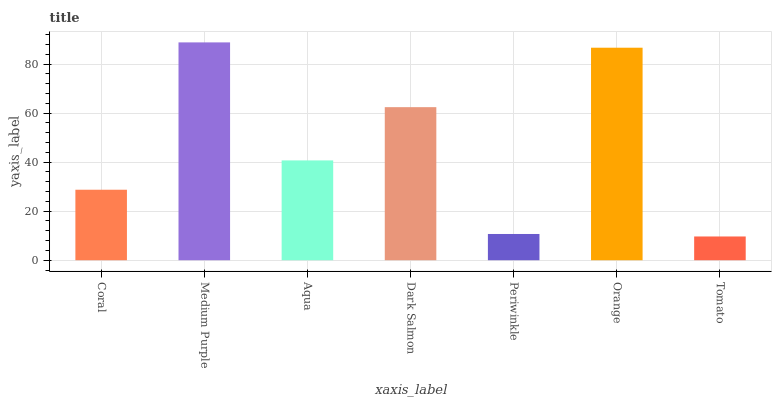Is Tomato the minimum?
Answer yes or no. Yes. Is Medium Purple the maximum?
Answer yes or no. Yes. Is Aqua the minimum?
Answer yes or no. No. Is Aqua the maximum?
Answer yes or no. No. Is Medium Purple greater than Aqua?
Answer yes or no. Yes. Is Aqua less than Medium Purple?
Answer yes or no. Yes. Is Aqua greater than Medium Purple?
Answer yes or no. No. Is Medium Purple less than Aqua?
Answer yes or no. No. Is Aqua the high median?
Answer yes or no. Yes. Is Aqua the low median?
Answer yes or no. Yes. Is Dark Salmon the high median?
Answer yes or no. No. Is Medium Purple the low median?
Answer yes or no. No. 